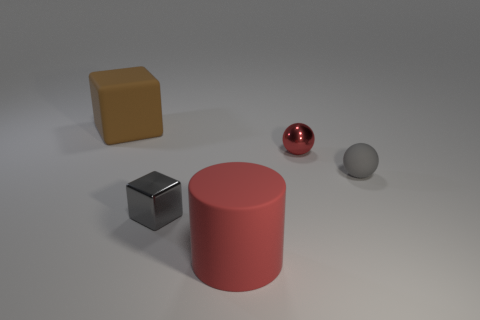What is the size of the other thing that is the same shape as the big brown thing?
Your answer should be compact. Small. Is the small cube the same color as the large matte cube?
Your response must be concise. No. There is a matte object that is both on the left side of the tiny rubber thing and in front of the brown matte cube; what is its color?
Provide a succinct answer. Red. There is a red thing that is behind the rubber cylinder; is it the same size as the small gray cube?
Offer a terse response. Yes. Is there any other thing that is the same shape as the big brown thing?
Your response must be concise. Yes. Does the large red thing have the same material as the block on the right side of the brown rubber cube?
Your answer should be compact. No. What number of green objects are matte things or large cylinders?
Your answer should be very brief. 0. Are there any metal objects?
Give a very brief answer. Yes. Are there any gray metal things on the right side of the big rubber object that is in front of the big matte object left of the metallic cube?
Keep it short and to the point. No. Is there any other thing that has the same size as the brown block?
Provide a short and direct response. Yes. 